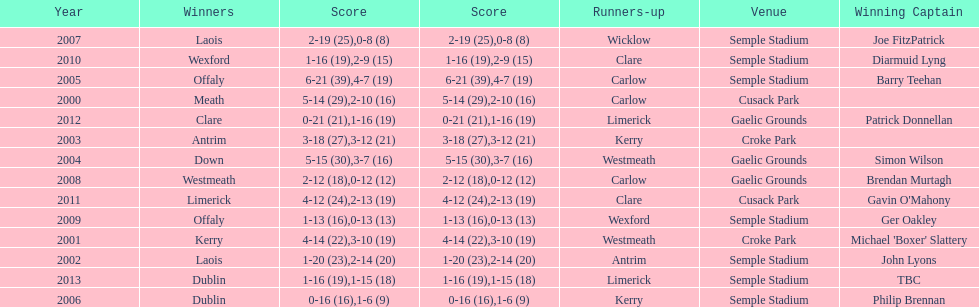Which team was the previous winner before dublin in 2013? Clare. 